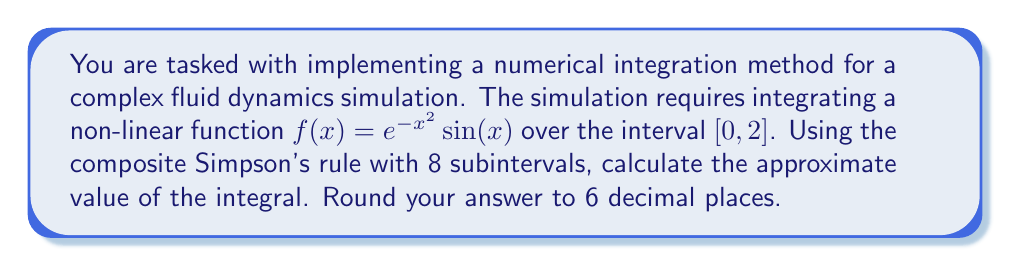Give your solution to this math problem. To solve this problem using the composite Simpson's rule, we'll follow these steps:

1) The composite Simpson's rule formula is:

   $$\int_a^b f(x) dx \approx \frac{h}{3} [f(x_0) + 4f(x_1) + 2f(x_2) + 4f(x_3) + ... + 2f(x_{n-2}) + 4f(x_{n-1}) + f(x_n)]$$

   where $h = \frac{b-a}{n}$, $n$ is the number of subintervals (must be even), and $x_i = a + ih$.

2) In our case, $a=0$, $b=2$, and $n=8$.

3) Calculate $h$:
   $h = \frac{2-0}{8} = 0.25$

4) Calculate the $x$ values:
   $x_0 = 0$
   $x_1 = 0.25$
   $x_2 = 0.50$
   $x_3 = 0.75$
   $x_4 = 1.00$
   $x_5 = 1.25$
   $x_6 = 1.50$
   $x_7 = 1.75$
   $x_8 = 2.00$

5) Calculate $f(x)$ for each $x$ value:
   $f(x_0) = e^{-0^2} \sin(0) = 0$
   $f(x_1) = e^{-0.25^2} \sin(0.25) \approx 0.246185$
   $f(x_2) = e^{-0.50^2} \sin(0.50) \approx 0.384780$
   $f(x_3) = e^{-0.75^2} \sin(0.75) \approx 0.399195$
   $f(x_4) = e^{-1.00^2} \sin(1.00) \approx 0.319560$
   $f(x_5) = e^{-1.25^2} \sin(1.25) \approx 0.197429$
   $f(x_6) = e^{-1.50^2} \sin(1.50) \approx 0.094922$
   $f(x_7) = e^{-1.75^2} \sin(1.75) \approx 0.035150$
   $f(x_8) = e^{-2.00^2} \sin(2.00) \approx 0.010052$

6) Apply the composite Simpson's rule:

   $$\frac{0.25}{3} [0 + 4(0.246185) + 2(0.384780) + 4(0.399195) + 2(0.319560) + 4(0.197429) + 2(0.094922) + 4(0.035150) + 0.010052]$$

7) Simplify:

   $$\frac{0.25}{3} [0 + 0.984740 + 0.769560 + 1.596780 + 0.639120 + 0.789716 + 0.189844 + 0.140600 + 0.010052] = 0.430804$$

8) Round to 6 decimal places: 0.430804
Answer: 0.430804 